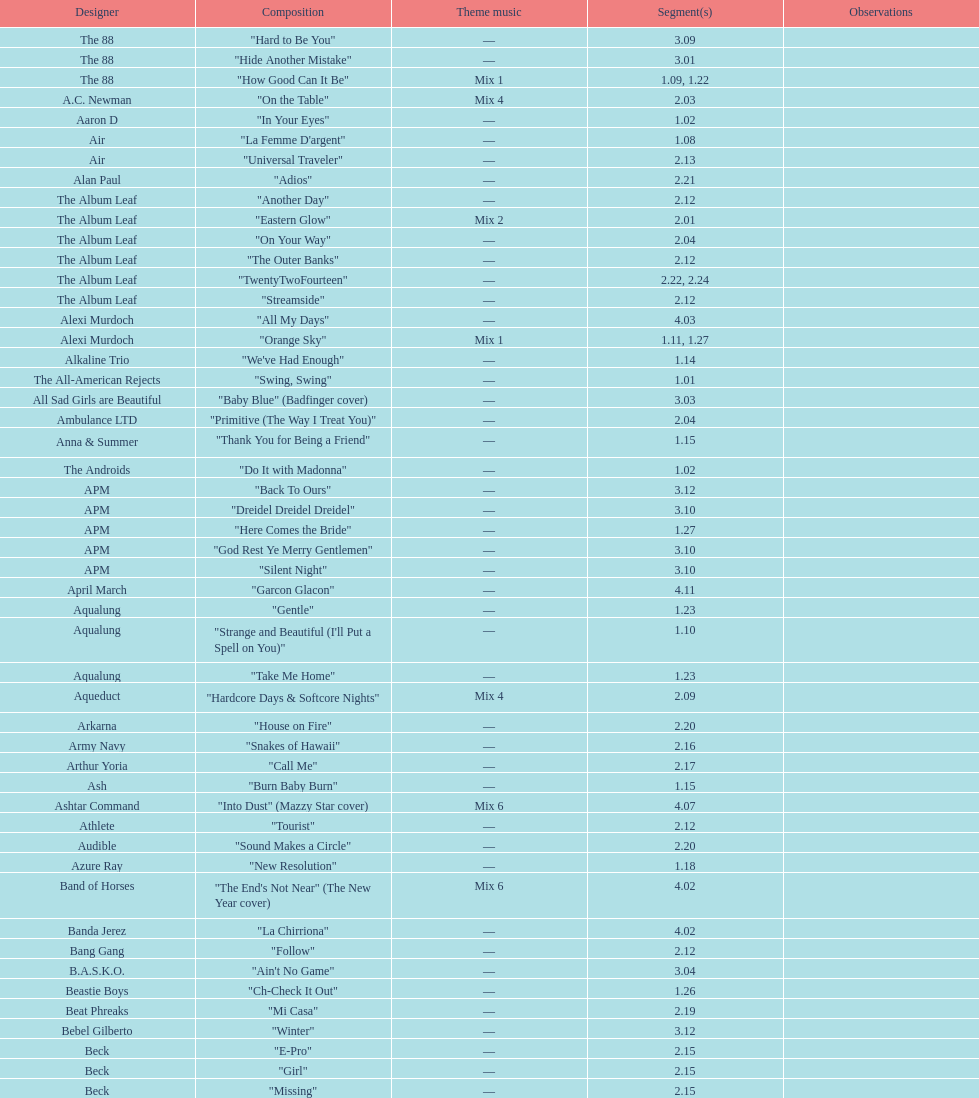What artist has more music appear in the show, daft punk or franz ferdinand? Franz Ferdinand. 